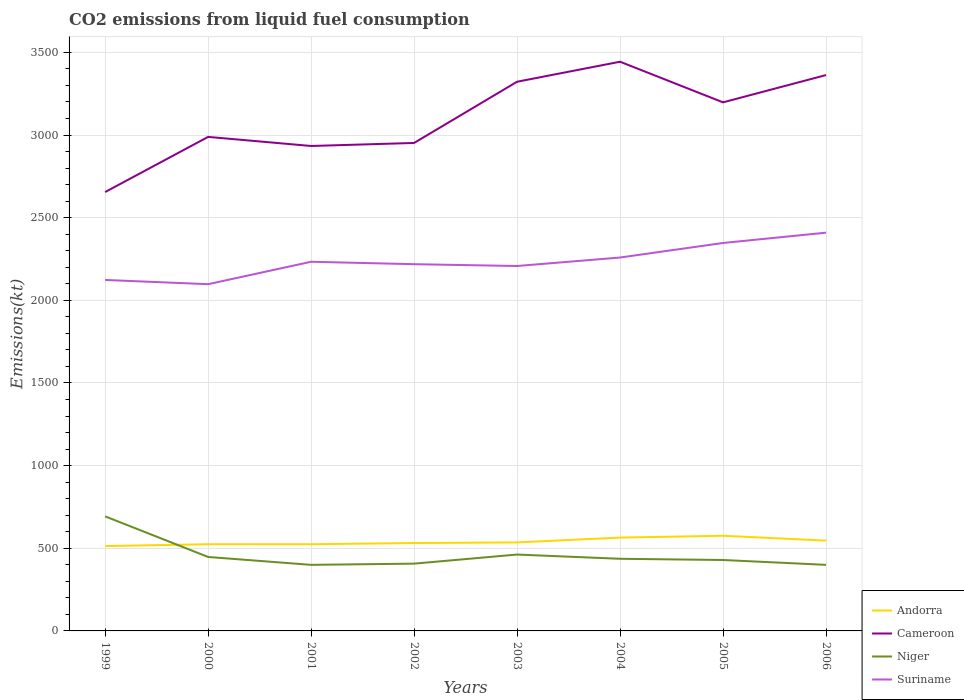How many different coloured lines are there?
Ensure brevity in your answer.  4. Is the number of lines equal to the number of legend labels?
Your answer should be very brief. Yes. Across all years, what is the maximum amount of CO2 emitted in Andorra?
Provide a short and direct response. 513.38. In which year was the amount of CO2 emitted in Niger maximum?
Your answer should be very brief. 2001. What is the total amount of CO2 emitted in Andorra in the graph?
Your answer should be compact. -62.34. What is the difference between the highest and the second highest amount of CO2 emitted in Cameroon?
Give a very brief answer. 788.41. What is the difference between the highest and the lowest amount of CO2 emitted in Andorra?
Your answer should be compact. 3. Is the amount of CO2 emitted in Niger strictly greater than the amount of CO2 emitted in Suriname over the years?
Your answer should be compact. Yes. How many years are there in the graph?
Provide a succinct answer. 8. What is the difference between two consecutive major ticks on the Y-axis?
Offer a very short reply. 500. Are the values on the major ticks of Y-axis written in scientific E-notation?
Your response must be concise. No. Does the graph contain grids?
Your response must be concise. Yes. How many legend labels are there?
Your answer should be very brief. 4. What is the title of the graph?
Keep it short and to the point. CO2 emissions from liquid fuel consumption. Does "Morocco" appear as one of the legend labels in the graph?
Keep it short and to the point. No. What is the label or title of the Y-axis?
Your answer should be compact. Emissions(kt). What is the Emissions(kt) in Andorra in 1999?
Make the answer very short. 513.38. What is the Emissions(kt) in Cameroon in 1999?
Your response must be concise. 2654.91. What is the Emissions(kt) of Niger in 1999?
Offer a very short reply. 693.06. What is the Emissions(kt) of Suriname in 1999?
Make the answer very short. 2123.19. What is the Emissions(kt) of Andorra in 2000?
Provide a short and direct response. 524.38. What is the Emissions(kt) in Cameroon in 2000?
Your answer should be very brief. 2988.61. What is the Emissions(kt) of Niger in 2000?
Provide a succinct answer. 447.37. What is the Emissions(kt) in Suriname in 2000?
Your answer should be very brief. 2097.52. What is the Emissions(kt) of Andorra in 2001?
Your answer should be very brief. 524.38. What is the Emissions(kt) of Cameroon in 2001?
Offer a very short reply. 2933.6. What is the Emissions(kt) of Niger in 2001?
Ensure brevity in your answer.  399.7. What is the Emissions(kt) in Suriname in 2001?
Your response must be concise. 2233.2. What is the Emissions(kt) in Andorra in 2002?
Your response must be concise. 531.72. What is the Emissions(kt) in Cameroon in 2002?
Give a very brief answer. 2951.93. What is the Emissions(kt) of Niger in 2002?
Your answer should be compact. 407.04. What is the Emissions(kt) in Suriname in 2002?
Your answer should be compact. 2218.53. What is the Emissions(kt) in Andorra in 2003?
Your answer should be compact. 535.38. What is the Emissions(kt) of Cameroon in 2003?
Give a very brief answer. 3322.3. What is the Emissions(kt) in Niger in 2003?
Your answer should be compact. 462.04. What is the Emissions(kt) in Suriname in 2003?
Make the answer very short. 2207.53. What is the Emissions(kt) of Andorra in 2004?
Ensure brevity in your answer.  564.72. What is the Emissions(kt) of Cameroon in 2004?
Ensure brevity in your answer.  3443.31. What is the Emissions(kt) of Niger in 2004?
Your answer should be very brief. 436.37. What is the Emissions(kt) in Suriname in 2004?
Your response must be concise. 2258.87. What is the Emissions(kt) of Andorra in 2005?
Provide a succinct answer. 575.72. What is the Emissions(kt) in Cameroon in 2005?
Provide a short and direct response. 3197.62. What is the Emissions(kt) of Niger in 2005?
Provide a short and direct response. 429.04. What is the Emissions(kt) in Suriname in 2005?
Provide a succinct answer. 2346.88. What is the Emissions(kt) of Andorra in 2006?
Offer a very short reply. 546.38. What is the Emissions(kt) in Cameroon in 2006?
Your answer should be very brief. 3362.64. What is the Emissions(kt) in Niger in 2006?
Keep it short and to the point. 399.7. What is the Emissions(kt) of Suriname in 2006?
Your answer should be very brief. 2409.22. Across all years, what is the maximum Emissions(kt) of Andorra?
Make the answer very short. 575.72. Across all years, what is the maximum Emissions(kt) in Cameroon?
Make the answer very short. 3443.31. Across all years, what is the maximum Emissions(kt) of Niger?
Make the answer very short. 693.06. Across all years, what is the maximum Emissions(kt) in Suriname?
Offer a terse response. 2409.22. Across all years, what is the minimum Emissions(kt) of Andorra?
Give a very brief answer. 513.38. Across all years, what is the minimum Emissions(kt) of Cameroon?
Ensure brevity in your answer.  2654.91. Across all years, what is the minimum Emissions(kt) of Niger?
Your response must be concise. 399.7. Across all years, what is the minimum Emissions(kt) in Suriname?
Provide a succinct answer. 2097.52. What is the total Emissions(kt) in Andorra in the graph?
Make the answer very short. 4316.06. What is the total Emissions(kt) in Cameroon in the graph?
Provide a succinct answer. 2.49e+04. What is the total Emissions(kt) in Niger in the graph?
Ensure brevity in your answer.  3674.33. What is the total Emissions(kt) in Suriname in the graph?
Keep it short and to the point. 1.79e+04. What is the difference between the Emissions(kt) in Andorra in 1999 and that in 2000?
Keep it short and to the point. -11. What is the difference between the Emissions(kt) in Cameroon in 1999 and that in 2000?
Offer a terse response. -333.7. What is the difference between the Emissions(kt) of Niger in 1999 and that in 2000?
Your answer should be compact. 245.69. What is the difference between the Emissions(kt) in Suriname in 1999 and that in 2000?
Provide a short and direct response. 25.67. What is the difference between the Emissions(kt) of Andorra in 1999 and that in 2001?
Your answer should be compact. -11. What is the difference between the Emissions(kt) in Cameroon in 1999 and that in 2001?
Make the answer very short. -278.69. What is the difference between the Emissions(kt) in Niger in 1999 and that in 2001?
Your answer should be compact. 293.36. What is the difference between the Emissions(kt) of Suriname in 1999 and that in 2001?
Offer a very short reply. -110.01. What is the difference between the Emissions(kt) of Andorra in 1999 and that in 2002?
Offer a terse response. -18.34. What is the difference between the Emissions(kt) of Cameroon in 1999 and that in 2002?
Provide a succinct answer. -297.03. What is the difference between the Emissions(kt) of Niger in 1999 and that in 2002?
Your answer should be very brief. 286.03. What is the difference between the Emissions(kt) of Suriname in 1999 and that in 2002?
Ensure brevity in your answer.  -95.34. What is the difference between the Emissions(kt) of Andorra in 1999 and that in 2003?
Give a very brief answer. -22. What is the difference between the Emissions(kt) in Cameroon in 1999 and that in 2003?
Provide a succinct answer. -667.39. What is the difference between the Emissions(kt) in Niger in 1999 and that in 2003?
Keep it short and to the point. 231.02. What is the difference between the Emissions(kt) of Suriname in 1999 and that in 2003?
Keep it short and to the point. -84.34. What is the difference between the Emissions(kt) of Andorra in 1999 and that in 2004?
Offer a terse response. -51.34. What is the difference between the Emissions(kt) of Cameroon in 1999 and that in 2004?
Offer a very short reply. -788.4. What is the difference between the Emissions(kt) of Niger in 1999 and that in 2004?
Offer a terse response. 256.69. What is the difference between the Emissions(kt) in Suriname in 1999 and that in 2004?
Make the answer very short. -135.68. What is the difference between the Emissions(kt) of Andorra in 1999 and that in 2005?
Provide a succinct answer. -62.34. What is the difference between the Emissions(kt) of Cameroon in 1999 and that in 2005?
Your answer should be very brief. -542.72. What is the difference between the Emissions(kt) of Niger in 1999 and that in 2005?
Provide a succinct answer. 264.02. What is the difference between the Emissions(kt) of Suriname in 1999 and that in 2005?
Ensure brevity in your answer.  -223.69. What is the difference between the Emissions(kt) in Andorra in 1999 and that in 2006?
Your answer should be very brief. -33. What is the difference between the Emissions(kt) in Cameroon in 1999 and that in 2006?
Ensure brevity in your answer.  -707.73. What is the difference between the Emissions(kt) in Niger in 1999 and that in 2006?
Provide a short and direct response. 293.36. What is the difference between the Emissions(kt) in Suriname in 1999 and that in 2006?
Offer a very short reply. -286.03. What is the difference between the Emissions(kt) of Cameroon in 2000 and that in 2001?
Keep it short and to the point. 55.01. What is the difference between the Emissions(kt) of Niger in 2000 and that in 2001?
Your response must be concise. 47.67. What is the difference between the Emissions(kt) of Suriname in 2000 and that in 2001?
Your answer should be compact. -135.68. What is the difference between the Emissions(kt) of Andorra in 2000 and that in 2002?
Offer a terse response. -7.33. What is the difference between the Emissions(kt) in Cameroon in 2000 and that in 2002?
Provide a succinct answer. 36.67. What is the difference between the Emissions(kt) of Niger in 2000 and that in 2002?
Offer a very short reply. 40.34. What is the difference between the Emissions(kt) in Suriname in 2000 and that in 2002?
Ensure brevity in your answer.  -121.01. What is the difference between the Emissions(kt) in Andorra in 2000 and that in 2003?
Offer a terse response. -11. What is the difference between the Emissions(kt) in Cameroon in 2000 and that in 2003?
Your response must be concise. -333.7. What is the difference between the Emissions(kt) in Niger in 2000 and that in 2003?
Offer a very short reply. -14.67. What is the difference between the Emissions(kt) of Suriname in 2000 and that in 2003?
Your answer should be very brief. -110.01. What is the difference between the Emissions(kt) of Andorra in 2000 and that in 2004?
Provide a succinct answer. -40.34. What is the difference between the Emissions(kt) of Cameroon in 2000 and that in 2004?
Provide a short and direct response. -454.71. What is the difference between the Emissions(kt) of Niger in 2000 and that in 2004?
Give a very brief answer. 11. What is the difference between the Emissions(kt) in Suriname in 2000 and that in 2004?
Keep it short and to the point. -161.35. What is the difference between the Emissions(kt) of Andorra in 2000 and that in 2005?
Make the answer very short. -51.34. What is the difference between the Emissions(kt) of Cameroon in 2000 and that in 2005?
Make the answer very short. -209.02. What is the difference between the Emissions(kt) in Niger in 2000 and that in 2005?
Provide a succinct answer. 18.34. What is the difference between the Emissions(kt) of Suriname in 2000 and that in 2005?
Ensure brevity in your answer.  -249.36. What is the difference between the Emissions(kt) in Andorra in 2000 and that in 2006?
Offer a very short reply. -22. What is the difference between the Emissions(kt) of Cameroon in 2000 and that in 2006?
Make the answer very short. -374.03. What is the difference between the Emissions(kt) in Niger in 2000 and that in 2006?
Keep it short and to the point. 47.67. What is the difference between the Emissions(kt) of Suriname in 2000 and that in 2006?
Make the answer very short. -311.69. What is the difference between the Emissions(kt) of Andorra in 2001 and that in 2002?
Offer a very short reply. -7.33. What is the difference between the Emissions(kt) in Cameroon in 2001 and that in 2002?
Provide a short and direct response. -18.34. What is the difference between the Emissions(kt) of Niger in 2001 and that in 2002?
Keep it short and to the point. -7.33. What is the difference between the Emissions(kt) of Suriname in 2001 and that in 2002?
Offer a very short reply. 14.67. What is the difference between the Emissions(kt) of Andorra in 2001 and that in 2003?
Give a very brief answer. -11. What is the difference between the Emissions(kt) of Cameroon in 2001 and that in 2003?
Make the answer very short. -388.7. What is the difference between the Emissions(kt) in Niger in 2001 and that in 2003?
Provide a succinct answer. -62.34. What is the difference between the Emissions(kt) in Suriname in 2001 and that in 2003?
Give a very brief answer. 25.67. What is the difference between the Emissions(kt) of Andorra in 2001 and that in 2004?
Keep it short and to the point. -40.34. What is the difference between the Emissions(kt) in Cameroon in 2001 and that in 2004?
Offer a very short reply. -509.71. What is the difference between the Emissions(kt) of Niger in 2001 and that in 2004?
Provide a succinct answer. -36.67. What is the difference between the Emissions(kt) of Suriname in 2001 and that in 2004?
Your answer should be very brief. -25.67. What is the difference between the Emissions(kt) of Andorra in 2001 and that in 2005?
Provide a short and direct response. -51.34. What is the difference between the Emissions(kt) in Cameroon in 2001 and that in 2005?
Keep it short and to the point. -264.02. What is the difference between the Emissions(kt) in Niger in 2001 and that in 2005?
Provide a succinct answer. -29.34. What is the difference between the Emissions(kt) in Suriname in 2001 and that in 2005?
Keep it short and to the point. -113.68. What is the difference between the Emissions(kt) in Andorra in 2001 and that in 2006?
Provide a short and direct response. -22. What is the difference between the Emissions(kt) of Cameroon in 2001 and that in 2006?
Your response must be concise. -429.04. What is the difference between the Emissions(kt) in Niger in 2001 and that in 2006?
Your response must be concise. 0. What is the difference between the Emissions(kt) of Suriname in 2001 and that in 2006?
Keep it short and to the point. -176.02. What is the difference between the Emissions(kt) of Andorra in 2002 and that in 2003?
Your answer should be very brief. -3.67. What is the difference between the Emissions(kt) of Cameroon in 2002 and that in 2003?
Offer a terse response. -370.37. What is the difference between the Emissions(kt) of Niger in 2002 and that in 2003?
Give a very brief answer. -55.01. What is the difference between the Emissions(kt) in Suriname in 2002 and that in 2003?
Ensure brevity in your answer.  11. What is the difference between the Emissions(kt) of Andorra in 2002 and that in 2004?
Give a very brief answer. -33. What is the difference between the Emissions(kt) in Cameroon in 2002 and that in 2004?
Ensure brevity in your answer.  -491.38. What is the difference between the Emissions(kt) of Niger in 2002 and that in 2004?
Provide a succinct answer. -29.34. What is the difference between the Emissions(kt) in Suriname in 2002 and that in 2004?
Provide a short and direct response. -40.34. What is the difference between the Emissions(kt) of Andorra in 2002 and that in 2005?
Your answer should be compact. -44. What is the difference between the Emissions(kt) in Cameroon in 2002 and that in 2005?
Offer a terse response. -245.69. What is the difference between the Emissions(kt) of Niger in 2002 and that in 2005?
Ensure brevity in your answer.  -22. What is the difference between the Emissions(kt) of Suriname in 2002 and that in 2005?
Provide a short and direct response. -128.34. What is the difference between the Emissions(kt) in Andorra in 2002 and that in 2006?
Make the answer very short. -14.67. What is the difference between the Emissions(kt) of Cameroon in 2002 and that in 2006?
Offer a terse response. -410.7. What is the difference between the Emissions(kt) of Niger in 2002 and that in 2006?
Your answer should be compact. 7.33. What is the difference between the Emissions(kt) in Suriname in 2002 and that in 2006?
Make the answer very short. -190.68. What is the difference between the Emissions(kt) in Andorra in 2003 and that in 2004?
Offer a very short reply. -29.34. What is the difference between the Emissions(kt) of Cameroon in 2003 and that in 2004?
Your answer should be compact. -121.01. What is the difference between the Emissions(kt) in Niger in 2003 and that in 2004?
Your answer should be compact. 25.67. What is the difference between the Emissions(kt) in Suriname in 2003 and that in 2004?
Make the answer very short. -51.34. What is the difference between the Emissions(kt) of Andorra in 2003 and that in 2005?
Provide a succinct answer. -40.34. What is the difference between the Emissions(kt) of Cameroon in 2003 and that in 2005?
Give a very brief answer. 124.68. What is the difference between the Emissions(kt) in Niger in 2003 and that in 2005?
Your answer should be very brief. 33. What is the difference between the Emissions(kt) of Suriname in 2003 and that in 2005?
Keep it short and to the point. -139.35. What is the difference between the Emissions(kt) of Andorra in 2003 and that in 2006?
Give a very brief answer. -11. What is the difference between the Emissions(kt) in Cameroon in 2003 and that in 2006?
Offer a terse response. -40.34. What is the difference between the Emissions(kt) in Niger in 2003 and that in 2006?
Give a very brief answer. 62.34. What is the difference between the Emissions(kt) in Suriname in 2003 and that in 2006?
Provide a short and direct response. -201.69. What is the difference between the Emissions(kt) in Andorra in 2004 and that in 2005?
Make the answer very short. -11. What is the difference between the Emissions(kt) of Cameroon in 2004 and that in 2005?
Your answer should be very brief. 245.69. What is the difference between the Emissions(kt) of Niger in 2004 and that in 2005?
Your answer should be compact. 7.33. What is the difference between the Emissions(kt) in Suriname in 2004 and that in 2005?
Keep it short and to the point. -88.01. What is the difference between the Emissions(kt) of Andorra in 2004 and that in 2006?
Your response must be concise. 18.34. What is the difference between the Emissions(kt) in Cameroon in 2004 and that in 2006?
Your answer should be very brief. 80.67. What is the difference between the Emissions(kt) in Niger in 2004 and that in 2006?
Your answer should be compact. 36.67. What is the difference between the Emissions(kt) in Suriname in 2004 and that in 2006?
Provide a short and direct response. -150.35. What is the difference between the Emissions(kt) of Andorra in 2005 and that in 2006?
Ensure brevity in your answer.  29.34. What is the difference between the Emissions(kt) in Cameroon in 2005 and that in 2006?
Give a very brief answer. -165.01. What is the difference between the Emissions(kt) of Niger in 2005 and that in 2006?
Ensure brevity in your answer.  29.34. What is the difference between the Emissions(kt) in Suriname in 2005 and that in 2006?
Give a very brief answer. -62.34. What is the difference between the Emissions(kt) in Andorra in 1999 and the Emissions(kt) in Cameroon in 2000?
Provide a succinct answer. -2475.22. What is the difference between the Emissions(kt) of Andorra in 1999 and the Emissions(kt) of Niger in 2000?
Ensure brevity in your answer.  66.01. What is the difference between the Emissions(kt) of Andorra in 1999 and the Emissions(kt) of Suriname in 2000?
Make the answer very short. -1584.14. What is the difference between the Emissions(kt) in Cameroon in 1999 and the Emissions(kt) in Niger in 2000?
Offer a very short reply. 2207.53. What is the difference between the Emissions(kt) of Cameroon in 1999 and the Emissions(kt) of Suriname in 2000?
Your answer should be very brief. 557.38. What is the difference between the Emissions(kt) of Niger in 1999 and the Emissions(kt) of Suriname in 2000?
Provide a succinct answer. -1404.46. What is the difference between the Emissions(kt) in Andorra in 1999 and the Emissions(kt) in Cameroon in 2001?
Ensure brevity in your answer.  -2420.22. What is the difference between the Emissions(kt) in Andorra in 1999 and the Emissions(kt) in Niger in 2001?
Your answer should be compact. 113.68. What is the difference between the Emissions(kt) in Andorra in 1999 and the Emissions(kt) in Suriname in 2001?
Offer a terse response. -1719.82. What is the difference between the Emissions(kt) in Cameroon in 1999 and the Emissions(kt) in Niger in 2001?
Your answer should be very brief. 2255.2. What is the difference between the Emissions(kt) in Cameroon in 1999 and the Emissions(kt) in Suriname in 2001?
Provide a succinct answer. 421.7. What is the difference between the Emissions(kt) of Niger in 1999 and the Emissions(kt) of Suriname in 2001?
Provide a short and direct response. -1540.14. What is the difference between the Emissions(kt) in Andorra in 1999 and the Emissions(kt) in Cameroon in 2002?
Your answer should be compact. -2438.55. What is the difference between the Emissions(kt) in Andorra in 1999 and the Emissions(kt) in Niger in 2002?
Give a very brief answer. 106.34. What is the difference between the Emissions(kt) in Andorra in 1999 and the Emissions(kt) in Suriname in 2002?
Offer a very short reply. -1705.15. What is the difference between the Emissions(kt) of Cameroon in 1999 and the Emissions(kt) of Niger in 2002?
Give a very brief answer. 2247.87. What is the difference between the Emissions(kt) in Cameroon in 1999 and the Emissions(kt) in Suriname in 2002?
Offer a very short reply. 436.37. What is the difference between the Emissions(kt) of Niger in 1999 and the Emissions(kt) of Suriname in 2002?
Give a very brief answer. -1525.47. What is the difference between the Emissions(kt) in Andorra in 1999 and the Emissions(kt) in Cameroon in 2003?
Your response must be concise. -2808.92. What is the difference between the Emissions(kt) in Andorra in 1999 and the Emissions(kt) in Niger in 2003?
Your answer should be compact. 51.34. What is the difference between the Emissions(kt) of Andorra in 1999 and the Emissions(kt) of Suriname in 2003?
Keep it short and to the point. -1694.15. What is the difference between the Emissions(kt) in Cameroon in 1999 and the Emissions(kt) in Niger in 2003?
Make the answer very short. 2192.87. What is the difference between the Emissions(kt) in Cameroon in 1999 and the Emissions(kt) in Suriname in 2003?
Provide a succinct answer. 447.37. What is the difference between the Emissions(kt) in Niger in 1999 and the Emissions(kt) in Suriname in 2003?
Provide a short and direct response. -1514.47. What is the difference between the Emissions(kt) in Andorra in 1999 and the Emissions(kt) in Cameroon in 2004?
Provide a short and direct response. -2929.93. What is the difference between the Emissions(kt) of Andorra in 1999 and the Emissions(kt) of Niger in 2004?
Your answer should be very brief. 77.01. What is the difference between the Emissions(kt) in Andorra in 1999 and the Emissions(kt) in Suriname in 2004?
Provide a succinct answer. -1745.49. What is the difference between the Emissions(kt) in Cameroon in 1999 and the Emissions(kt) in Niger in 2004?
Ensure brevity in your answer.  2218.53. What is the difference between the Emissions(kt) of Cameroon in 1999 and the Emissions(kt) of Suriname in 2004?
Provide a succinct answer. 396.04. What is the difference between the Emissions(kt) of Niger in 1999 and the Emissions(kt) of Suriname in 2004?
Provide a succinct answer. -1565.81. What is the difference between the Emissions(kt) of Andorra in 1999 and the Emissions(kt) of Cameroon in 2005?
Ensure brevity in your answer.  -2684.24. What is the difference between the Emissions(kt) in Andorra in 1999 and the Emissions(kt) in Niger in 2005?
Ensure brevity in your answer.  84.34. What is the difference between the Emissions(kt) of Andorra in 1999 and the Emissions(kt) of Suriname in 2005?
Your answer should be very brief. -1833.5. What is the difference between the Emissions(kt) in Cameroon in 1999 and the Emissions(kt) in Niger in 2005?
Make the answer very short. 2225.87. What is the difference between the Emissions(kt) of Cameroon in 1999 and the Emissions(kt) of Suriname in 2005?
Provide a short and direct response. 308.03. What is the difference between the Emissions(kt) in Niger in 1999 and the Emissions(kt) in Suriname in 2005?
Offer a very short reply. -1653.82. What is the difference between the Emissions(kt) of Andorra in 1999 and the Emissions(kt) of Cameroon in 2006?
Your response must be concise. -2849.26. What is the difference between the Emissions(kt) in Andorra in 1999 and the Emissions(kt) in Niger in 2006?
Make the answer very short. 113.68. What is the difference between the Emissions(kt) of Andorra in 1999 and the Emissions(kt) of Suriname in 2006?
Give a very brief answer. -1895.84. What is the difference between the Emissions(kt) of Cameroon in 1999 and the Emissions(kt) of Niger in 2006?
Your answer should be compact. 2255.2. What is the difference between the Emissions(kt) of Cameroon in 1999 and the Emissions(kt) of Suriname in 2006?
Offer a very short reply. 245.69. What is the difference between the Emissions(kt) in Niger in 1999 and the Emissions(kt) in Suriname in 2006?
Ensure brevity in your answer.  -1716.16. What is the difference between the Emissions(kt) of Andorra in 2000 and the Emissions(kt) of Cameroon in 2001?
Provide a short and direct response. -2409.22. What is the difference between the Emissions(kt) of Andorra in 2000 and the Emissions(kt) of Niger in 2001?
Your response must be concise. 124.68. What is the difference between the Emissions(kt) in Andorra in 2000 and the Emissions(kt) in Suriname in 2001?
Offer a terse response. -1708.82. What is the difference between the Emissions(kt) of Cameroon in 2000 and the Emissions(kt) of Niger in 2001?
Offer a very short reply. 2588.9. What is the difference between the Emissions(kt) of Cameroon in 2000 and the Emissions(kt) of Suriname in 2001?
Your answer should be compact. 755.4. What is the difference between the Emissions(kt) of Niger in 2000 and the Emissions(kt) of Suriname in 2001?
Offer a terse response. -1785.83. What is the difference between the Emissions(kt) in Andorra in 2000 and the Emissions(kt) in Cameroon in 2002?
Your answer should be very brief. -2427.55. What is the difference between the Emissions(kt) of Andorra in 2000 and the Emissions(kt) of Niger in 2002?
Your answer should be very brief. 117.34. What is the difference between the Emissions(kt) of Andorra in 2000 and the Emissions(kt) of Suriname in 2002?
Provide a short and direct response. -1694.15. What is the difference between the Emissions(kt) in Cameroon in 2000 and the Emissions(kt) in Niger in 2002?
Your answer should be compact. 2581.57. What is the difference between the Emissions(kt) in Cameroon in 2000 and the Emissions(kt) in Suriname in 2002?
Ensure brevity in your answer.  770.07. What is the difference between the Emissions(kt) of Niger in 2000 and the Emissions(kt) of Suriname in 2002?
Offer a very short reply. -1771.16. What is the difference between the Emissions(kt) in Andorra in 2000 and the Emissions(kt) in Cameroon in 2003?
Provide a succinct answer. -2797.92. What is the difference between the Emissions(kt) in Andorra in 2000 and the Emissions(kt) in Niger in 2003?
Keep it short and to the point. 62.34. What is the difference between the Emissions(kt) of Andorra in 2000 and the Emissions(kt) of Suriname in 2003?
Provide a succinct answer. -1683.15. What is the difference between the Emissions(kt) in Cameroon in 2000 and the Emissions(kt) in Niger in 2003?
Give a very brief answer. 2526.56. What is the difference between the Emissions(kt) in Cameroon in 2000 and the Emissions(kt) in Suriname in 2003?
Your answer should be compact. 781.07. What is the difference between the Emissions(kt) of Niger in 2000 and the Emissions(kt) of Suriname in 2003?
Offer a very short reply. -1760.16. What is the difference between the Emissions(kt) of Andorra in 2000 and the Emissions(kt) of Cameroon in 2004?
Ensure brevity in your answer.  -2918.93. What is the difference between the Emissions(kt) of Andorra in 2000 and the Emissions(kt) of Niger in 2004?
Keep it short and to the point. 88.01. What is the difference between the Emissions(kt) of Andorra in 2000 and the Emissions(kt) of Suriname in 2004?
Provide a short and direct response. -1734.49. What is the difference between the Emissions(kt) of Cameroon in 2000 and the Emissions(kt) of Niger in 2004?
Your response must be concise. 2552.23. What is the difference between the Emissions(kt) of Cameroon in 2000 and the Emissions(kt) of Suriname in 2004?
Your answer should be very brief. 729.73. What is the difference between the Emissions(kt) in Niger in 2000 and the Emissions(kt) in Suriname in 2004?
Give a very brief answer. -1811.5. What is the difference between the Emissions(kt) of Andorra in 2000 and the Emissions(kt) of Cameroon in 2005?
Ensure brevity in your answer.  -2673.24. What is the difference between the Emissions(kt) in Andorra in 2000 and the Emissions(kt) in Niger in 2005?
Provide a short and direct response. 95.34. What is the difference between the Emissions(kt) of Andorra in 2000 and the Emissions(kt) of Suriname in 2005?
Offer a terse response. -1822.5. What is the difference between the Emissions(kt) in Cameroon in 2000 and the Emissions(kt) in Niger in 2005?
Your answer should be very brief. 2559.57. What is the difference between the Emissions(kt) in Cameroon in 2000 and the Emissions(kt) in Suriname in 2005?
Offer a very short reply. 641.73. What is the difference between the Emissions(kt) of Niger in 2000 and the Emissions(kt) of Suriname in 2005?
Provide a succinct answer. -1899.51. What is the difference between the Emissions(kt) of Andorra in 2000 and the Emissions(kt) of Cameroon in 2006?
Keep it short and to the point. -2838.26. What is the difference between the Emissions(kt) in Andorra in 2000 and the Emissions(kt) in Niger in 2006?
Offer a terse response. 124.68. What is the difference between the Emissions(kt) in Andorra in 2000 and the Emissions(kt) in Suriname in 2006?
Make the answer very short. -1884.84. What is the difference between the Emissions(kt) of Cameroon in 2000 and the Emissions(kt) of Niger in 2006?
Your answer should be very brief. 2588.9. What is the difference between the Emissions(kt) of Cameroon in 2000 and the Emissions(kt) of Suriname in 2006?
Offer a very short reply. 579.39. What is the difference between the Emissions(kt) of Niger in 2000 and the Emissions(kt) of Suriname in 2006?
Provide a short and direct response. -1961.85. What is the difference between the Emissions(kt) of Andorra in 2001 and the Emissions(kt) of Cameroon in 2002?
Your answer should be compact. -2427.55. What is the difference between the Emissions(kt) of Andorra in 2001 and the Emissions(kt) of Niger in 2002?
Provide a succinct answer. 117.34. What is the difference between the Emissions(kt) of Andorra in 2001 and the Emissions(kt) of Suriname in 2002?
Provide a short and direct response. -1694.15. What is the difference between the Emissions(kt) in Cameroon in 2001 and the Emissions(kt) in Niger in 2002?
Your response must be concise. 2526.56. What is the difference between the Emissions(kt) in Cameroon in 2001 and the Emissions(kt) in Suriname in 2002?
Provide a succinct answer. 715.07. What is the difference between the Emissions(kt) of Niger in 2001 and the Emissions(kt) of Suriname in 2002?
Provide a short and direct response. -1818.83. What is the difference between the Emissions(kt) in Andorra in 2001 and the Emissions(kt) in Cameroon in 2003?
Your response must be concise. -2797.92. What is the difference between the Emissions(kt) in Andorra in 2001 and the Emissions(kt) in Niger in 2003?
Your answer should be compact. 62.34. What is the difference between the Emissions(kt) in Andorra in 2001 and the Emissions(kt) in Suriname in 2003?
Your answer should be very brief. -1683.15. What is the difference between the Emissions(kt) in Cameroon in 2001 and the Emissions(kt) in Niger in 2003?
Give a very brief answer. 2471.56. What is the difference between the Emissions(kt) in Cameroon in 2001 and the Emissions(kt) in Suriname in 2003?
Offer a terse response. 726.07. What is the difference between the Emissions(kt) in Niger in 2001 and the Emissions(kt) in Suriname in 2003?
Make the answer very short. -1807.83. What is the difference between the Emissions(kt) in Andorra in 2001 and the Emissions(kt) in Cameroon in 2004?
Make the answer very short. -2918.93. What is the difference between the Emissions(kt) in Andorra in 2001 and the Emissions(kt) in Niger in 2004?
Offer a very short reply. 88.01. What is the difference between the Emissions(kt) in Andorra in 2001 and the Emissions(kt) in Suriname in 2004?
Your answer should be very brief. -1734.49. What is the difference between the Emissions(kt) in Cameroon in 2001 and the Emissions(kt) in Niger in 2004?
Ensure brevity in your answer.  2497.23. What is the difference between the Emissions(kt) in Cameroon in 2001 and the Emissions(kt) in Suriname in 2004?
Keep it short and to the point. 674.73. What is the difference between the Emissions(kt) of Niger in 2001 and the Emissions(kt) of Suriname in 2004?
Your answer should be very brief. -1859.17. What is the difference between the Emissions(kt) of Andorra in 2001 and the Emissions(kt) of Cameroon in 2005?
Your answer should be very brief. -2673.24. What is the difference between the Emissions(kt) of Andorra in 2001 and the Emissions(kt) of Niger in 2005?
Your answer should be very brief. 95.34. What is the difference between the Emissions(kt) in Andorra in 2001 and the Emissions(kt) in Suriname in 2005?
Ensure brevity in your answer.  -1822.5. What is the difference between the Emissions(kt) in Cameroon in 2001 and the Emissions(kt) in Niger in 2005?
Your answer should be very brief. 2504.56. What is the difference between the Emissions(kt) of Cameroon in 2001 and the Emissions(kt) of Suriname in 2005?
Your answer should be very brief. 586.72. What is the difference between the Emissions(kt) in Niger in 2001 and the Emissions(kt) in Suriname in 2005?
Offer a very short reply. -1947.18. What is the difference between the Emissions(kt) in Andorra in 2001 and the Emissions(kt) in Cameroon in 2006?
Ensure brevity in your answer.  -2838.26. What is the difference between the Emissions(kt) in Andorra in 2001 and the Emissions(kt) in Niger in 2006?
Give a very brief answer. 124.68. What is the difference between the Emissions(kt) in Andorra in 2001 and the Emissions(kt) in Suriname in 2006?
Your response must be concise. -1884.84. What is the difference between the Emissions(kt) in Cameroon in 2001 and the Emissions(kt) in Niger in 2006?
Keep it short and to the point. 2533.9. What is the difference between the Emissions(kt) in Cameroon in 2001 and the Emissions(kt) in Suriname in 2006?
Your answer should be compact. 524.38. What is the difference between the Emissions(kt) in Niger in 2001 and the Emissions(kt) in Suriname in 2006?
Give a very brief answer. -2009.52. What is the difference between the Emissions(kt) in Andorra in 2002 and the Emissions(kt) in Cameroon in 2003?
Ensure brevity in your answer.  -2790.59. What is the difference between the Emissions(kt) of Andorra in 2002 and the Emissions(kt) of Niger in 2003?
Provide a succinct answer. 69.67. What is the difference between the Emissions(kt) of Andorra in 2002 and the Emissions(kt) of Suriname in 2003?
Offer a very short reply. -1675.82. What is the difference between the Emissions(kt) in Cameroon in 2002 and the Emissions(kt) in Niger in 2003?
Give a very brief answer. 2489.89. What is the difference between the Emissions(kt) in Cameroon in 2002 and the Emissions(kt) in Suriname in 2003?
Ensure brevity in your answer.  744.4. What is the difference between the Emissions(kt) in Niger in 2002 and the Emissions(kt) in Suriname in 2003?
Offer a terse response. -1800.5. What is the difference between the Emissions(kt) in Andorra in 2002 and the Emissions(kt) in Cameroon in 2004?
Offer a very short reply. -2911.6. What is the difference between the Emissions(kt) of Andorra in 2002 and the Emissions(kt) of Niger in 2004?
Your answer should be compact. 95.34. What is the difference between the Emissions(kt) in Andorra in 2002 and the Emissions(kt) in Suriname in 2004?
Provide a short and direct response. -1727.16. What is the difference between the Emissions(kt) in Cameroon in 2002 and the Emissions(kt) in Niger in 2004?
Your response must be concise. 2515.56. What is the difference between the Emissions(kt) of Cameroon in 2002 and the Emissions(kt) of Suriname in 2004?
Make the answer very short. 693.06. What is the difference between the Emissions(kt) of Niger in 2002 and the Emissions(kt) of Suriname in 2004?
Provide a succinct answer. -1851.84. What is the difference between the Emissions(kt) of Andorra in 2002 and the Emissions(kt) of Cameroon in 2005?
Provide a short and direct response. -2665.91. What is the difference between the Emissions(kt) of Andorra in 2002 and the Emissions(kt) of Niger in 2005?
Keep it short and to the point. 102.68. What is the difference between the Emissions(kt) in Andorra in 2002 and the Emissions(kt) in Suriname in 2005?
Your answer should be very brief. -1815.16. What is the difference between the Emissions(kt) of Cameroon in 2002 and the Emissions(kt) of Niger in 2005?
Keep it short and to the point. 2522.9. What is the difference between the Emissions(kt) of Cameroon in 2002 and the Emissions(kt) of Suriname in 2005?
Give a very brief answer. 605.05. What is the difference between the Emissions(kt) of Niger in 2002 and the Emissions(kt) of Suriname in 2005?
Your answer should be very brief. -1939.84. What is the difference between the Emissions(kt) in Andorra in 2002 and the Emissions(kt) in Cameroon in 2006?
Provide a succinct answer. -2830.92. What is the difference between the Emissions(kt) in Andorra in 2002 and the Emissions(kt) in Niger in 2006?
Offer a very short reply. 132.01. What is the difference between the Emissions(kt) of Andorra in 2002 and the Emissions(kt) of Suriname in 2006?
Your answer should be very brief. -1877.5. What is the difference between the Emissions(kt) in Cameroon in 2002 and the Emissions(kt) in Niger in 2006?
Ensure brevity in your answer.  2552.23. What is the difference between the Emissions(kt) of Cameroon in 2002 and the Emissions(kt) of Suriname in 2006?
Provide a succinct answer. 542.72. What is the difference between the Emissions(kt) of Niger in 2002 and the Emissions(kt) of Suriname in 2006?
Keep it short and to the point. -2002.18. What is the difference between the Emissions(kt) of Andorra in 2003 and the Emissions(kt) of Cameroon in 2004?
Keep it short and to the point. -2907.93. What is the difference between the Emissions(kt) in Andorra in 2003 and the Emissions(kt) in Niger in 2004?
Your answer should be compact. 99.01. What is the difference between the Emissions(kt) of Andorra in 2003 and the Emissions(kt) of Suriname in 2004?
Provide a succinct answer. -1723.49. What is the difference between the Emissions(kt) of Cameroon in 2003 and the Emissions(kt) of Niger in 2004?
Provide a succinct answer. 2885.93. What is the difference between the Emissions(kt) in Cameroon in 2003 and the Emissions(kt) in Suriname in 2004?
Offer a very short reply. 1063.43. What is the difference between the Emissions(kt) in Niger in 2003 and the Emissions(kt) in Suriname in 2004?
Provide a short and direct response. -1796.83. What is the difference between the Emissions(kt) of Andorra in 2003 and the Emissions(kt) of Cameroon in 2005?
Your response must be concise. -2662.24. What is the difference between the Emissions(kt) in Andorra in 2003 and the Emissions(kt) in Niger in 2005?
Your response must be concise. 106.34. What is the difference between the Emissions(kt) in Andorra in 2003 and the Emissions(kt) in Suriname in 2005?
Your response must be concise. -1811.5. What is the difference between the Emissions(kt) in Cameroon in 2003 and the Emissions(kt) in Niger in 2005?
Your response must be concise. 2893.26. What is the difference between the Emissions(kt) of Cameroon in 2003 and the Emissions(kt) of Suriname in 2005?
Make the answer very short. 975.42. What is the difference between the Emissions(kt) in Niger in 2003 and the Emissions(kt) in Suriname in 2005?
Provide a short and direct response. -1884.84. What is the difference between the Emissions(kt) of Andorra in 2003 and the Emissions(kt) of Cameroon in 2006?
Ensure brevity in your answer.  -2827.26. What is the difference between the Emissions(kt) in Andorra in 2003 and the Emissions(kt) in Niger in 2006?
Give a very brief answer. 135.68. What is the difference between the Emissions(kt) of Andorra in 2003 and the Emissions(kt) of Suriname in 2006?
Make the answer very short. -1873.84. What is the difference between the Emissions(kt) of Cameroon in 2003 and the Emissions(kt) of Niger in 2006?
Ensure brevity in your answer.  2922.6. What is the difference between the Emissions(kt) of Cameroon in 2003 and the Emissions(kt) of Suriname in 2006?
Your answer should be very brief. 913.08. What is the difference between the Emissions(kt) of Niger in 2003 and the Emissions(kt) of Suriname in 2006?
Keep it short and to the point. -1947.18. What is the difference between the Emissions(kt) of Andorra in 2004 and the Emissions(kt) of Cameroon in 2005?
Keep it short and to the point. -2632.91. What is the difference between the Emissions(kt) of Andorra in 2004 and the Emissions(kt) of Niger in 2005?
Give a very brief answer. 135.68. What is the difference between the Emissions(kt) in Andorra in 2004 and the Emissions(kt) in Suriname in 2005?
Your response must be concise. -1782.16. What is the difference between the Emissions(kt) in Cameroon in 2004 and the Emissions(kt) in Niger in 2005?
Your answer should be compact. 3014.27. What is the difference between the Emissions(kt) in Cameroon in 2004 and the Emissions(kt) in Suriname in 2005?
Give a very brief answer. 1096.43. What is the difference between the Emissions(kt) in Niger in 2004 and the Emissions(kt) in Suriname in 2005?
Provide a succinct answer. -1910.51. What is the difference between the Emissions(kt) of Andorra in 2004 and the Emissions(kt) of Cameroon in 2006?
Your answer should be compact. -2797.92. What is the difference between the Emissions(kt) in Andorra in 2004 and the Emissions(kt) in Niger in 2006?
Make the answer very short. 165.01. What is the difference between the Emissions(kt) of Andorra in 2004 and the Emissions(kt) of Suriname in 2006?
Offer a very short reply. -1844.5. What is the difference between the Emissions(kt) in Cameroon in 2004 and the Emissions(kt) in Niger in 2006?
Offer a very short reply. 3043.61. What is the difference between the Emissions(kt) of Cameroon in 2004 and the Emissions(kt) of Suriname in 2006?
Keep it short and to the point. 1034.09. What is the difference between the Emissions(kt) of Niger in 2004 and the Emissions(kt) of Suriname in 2006?
Keep it short and to the point. -1972.85. What is the difference between the Emissions(kt) in Andorra in 2005 and the Emissions(kt) in Cameroon in 2006?
Offer a terse response. -2786.92. What is the difference between the Emissions(kt) of Andorra in 2005 and the Emissions(kt) of Niger in 2006?
Provide a short and direct response. 176.02. What is the difference between the Emissions(kt) in Andorra in 2005 and the Emissions(kt) in Suriname in 2006?
Your answer should be very brief. -1833.5. What is the difference between the Emissions(kt) in Cameroon in 2005 and the Emissions(kt) in Niger in 2006?
Make the answer very short. 2797.92. What is the difference between the Emissions(kt) in Cameroon in 2005 and the Emissions(kt) in Suriname in 2006?
Keep it short and to the point. 788.4. What is the difference between the Emissions(kt) in Niger in 2005 and the Emissions(kt) in Suriname in 2006?
Keep it short and to the point. -1980.18. What is the average Emissions(kt) in Andorra per year?
Your response must be concise. 539.51. What is the average Emissions(kt) in Cameroon per year?
Provide a succinct answer. 3106.87. What is the average Emissions(kt) of Niger per year?
Offer a very short reply. 459.29. What is the average Emissions(kt) in Suriname per year?
Your response must be concise. 2236.87. In the year 1999, what is the difference between the Emissions(kt) of Andorra and Emissions(kt) of Cameroon?
Give a very brief answer. -2141.53. In the year 1999, what is the difference between the Emissions(kt) in Andorra and Emissions(kt) in Niger?
Offer a very short reply. -179.68. In the year 1999, what is the difference between the Emissions(kt) in Andorra and Emissions(kt) in Suriname?
Your response must be concise. -1609.81. In the year 1999, what is the difference between the Emissions(kt) of Cameroon and Emissions(kt) of Niger?
Your answer should be compact. 1961.85. In the year 1999, what is the difference between the Emissions(kt) of Cameroon and Emissions(kt) of Suriname?
Provide a succinct answer. 531.72. In the year 1999, what is the difference between the Emissions(kt) in Niger and Emissions(kt) in Suriname?
Make the answer very short. -1430.13. In the year 2000, what is the difference between the Emissions(kt) of Andorra and Emissions(kt) of Cameroon?
Offer a very short reply. -2464.22. In the year 2000, what is the difference between the Emissions(kt) of Andorra and Emissions(kt) of Niger?
Ensure brevity in your answer.  77.01. In the year 2000, what is the difference between the Emissions(kt) in Andorra and Emissions(kt) in Suriname?
Your answer should be compact. -1573.14. In the year 2000, what is the difference between the Emissions(kt) in Cameroon and Emissions(kt) in Niger?
Give a very brief answer. 2541.23. In the year 2000, what is the difference between the Emissions(kt) of Cameroon and Emissions(kt) of Suriname?
Provide a succinct answer. 891.08. In the year 2000, what is the difference between the Emissions(kt) in Niger and Emissions(kt) in Suriname?
Offer a terse response. -1650.15. In the year 2001, what is the difference between the Emissions(kt) in Andorra and Emissions(kt) in Cameroon?
Keep it short and to the point. -2409.22. In the year 2001, what is the difference between the Emissions(kt) of Andorra and Emissions(kt) of Niger?
Provide a succinct answer. 124.68. In the year 2001, what is the difference between the Emissions(kt) of Andorra and Emissions(kt) of Suriname?
Give a very brief answer. -1708.82. In the year 2001, what is the difference between the Emissions(kt) in Cameroon and Emissions(kt) in Niger?
Make the answer very short. 2533.9. In the year 2001, what is the difference between the Emissions(kt) of Cameroon and Emissions(kt) of Suriname?
Provide a succinct answer. 700.4. In the year 2001, what is the difference between the Emissions(kt) of Niger and Emissions(kt) of Suriname?
Your answer should be very brief. -1833.5. In the year 2002, what is the difference between the Emissions(kt) of Andorra and Emissions(kt) of Cameroon?
Keep it short and to the point. -2420.22. In the year 2002, what is the difference between the Emissions(kt) in Andorra and Emissions(kt) in Niger?
Your response must be concise. 124.68. In the year 2002, what is the difference between the Emissions(kt) of Andorra and Emissions(kt) of Suriname?
Provide a succinct answer. -1686.82. In the year 2002, what is the difference between the Emissions(kt) of Cameroon and Emissions(kt) of Niger?
Keep it short and to the point. 2544.9. In the year 2002, what is the difference between the Emissions(kt) in Cameroon and Emissions(kt) in Suriname?
Give a very brief answer. 733.4. In the year 2002, what is the difference between the Emissions(kt) in Niger and Emissions(kt) in Suriname?
Provide a succinct answer. -1811.5. In the year 2003, what is the difference between the Emissions(kt) in Andorra and Emissions(kt) in Cameroon?
Make the answer very short. -2786.92. In the year 2003, what is the difference between the Emissions(kt) in Andorra and Emissions(kt) in Niger?
Offer a very short reply. 73.34. In the year 2003, what is the difference between the Emissions(kt) of Andorra and Emissions(kt) of Suriname?
Provide a succinct answer. -1672.15. In the year 2003, what is the difference between the Emissions(kt) in Cameroon and Emissions(kt) in Niger?
Ensure brevity in your answer.  2860.26. In the year 2003, what is the difference between the Emissions(kt) in Cameroon and Emissions(kt) in Suriname?
Keep it short and to the point. 1114.77. In the year 2003, what is the difference between the Emissions(kt) in Niger and Emissions(kt) in Suriname?
Offer a very short reply. -1745.49. In the year 2004, what is the difference between the Emissions(kt) in Andorra and Emissions(kt) in Cameroon?
Your response must be concise. -2878.59. In the year 2004, what is the difference between the Emissions(kt) in Andorra and Emissions(kt) in Niger?
Give a very brief answer. 128.34. In the year 2004, what is the difference between the Emissions(kt) of Andorra and Emissions(kt) of Suriname?
Provide a short and direct response. -1694.15. In the year 2004, what is the difference between the Emissions(kt) in Cameroon and Emissions(kt) in Niger?
Provide a short and direct response. 3006.94. In the year 2004, what is the difference between the Emissions(kt) in Cameroon and Emissions(kt) in Suriname?
Provide a succinct answer. 1184.44. In the year 2004, what is the difference between the Emissions(kt) in Niger and Emissions(kt) in Suriname?
Provide a succinct answer. -1822.5. In the year 2005, what is the difference between the Emissions(kt) in Andorra and Emissions(kt) in Cameroon?
Ensure brevity in your answer.  -2621.91. In the year 2005, what is the difference between the Emissions(kt) of Andorra and Emissions(kt) of Niger?
Your response must be concise. 146.68. In the year 2005, what is the difference between the Emissions(kt) of Andorra and Emissions(kt) of Suriname?
Your response must be concise. -1771.16. In the year 2005, what is the difference between the Emissions(kt) in Cameroon and Emissions(kt) in Niger?
Offer a very short reply. 2768.59. In the year 2005, what is the difference between the Emissions(kt) in Cameroon and Emissions(kt) in Suriname?
Your response must be concise. 850.74. In the year 2005, what is the difference between the Emissions(kt) in Niger and Emissions(kt) in Suriname?
Your answer should be compact. -1917.84. In the year 2006, what is the difference between the Emissions(kt) in Andorra and Emissions(kt) in Cameroon?
Offer a terse response. -2816.26. In the year 2006, what is the difference between the Emissions(kt) in Andorra and Emissions(kt) in Niger?
Make the answer very short. 146.68. In the year 2006, what is the difference between the Emissions(kt) of Andorra and Emissions(kt) of Suriname?
Make the answer very short. -1862.84. In the year 2006, what is the difference between the Emissions(kt) of Cameroon and Emissions(kt) of Niger?
Your answer should be compact. 2962.94. In the year 2006, what is the difference between the Emissions(kt) in Cameroon and Emissions(kt) in Suriname?
Keep it short and to the point. 953.42. In the year 2006, what is the difference between the Emissions(kt) in Niger and Emissions(kt) in Suriname?
Keep it short and to the point. -2009.52. What is the ratio of the Emissions(kt) of Andorra in 1999 to that in 2000?
Your answer should be compact. 0.98. What is the ratio of the Emissions(kt) of Cameroon in 1999 to that in 2000?
Make the answer very short. 0.89. What is the ratio of the Emissions(kt) in Niger in 1999 to that in 2000?
Make the answer very short. 1.55. What is the ratio of the Emissions(kt) of Suriname in 1999 to that in 2000?
Your answer should be compact. 1.01. What is the ratio of the Emissions(kt) in Cameroon in 1999 to that in 2001?
Your answer should be very brief. 0.91. What is the ratio of the Emissions(kt) of Niger in 1999 to that in 2001?
Offer a very short reply. 1.73. What is the ratio of the Emissions(kt) of Suriname in 1999 to that in 2001?
Keep it short and to the point. 0.95. What is the ratio of the Emissions(kt) of Andorra in 1999 to that in 2002?
Your answer should be compact. 0.97. What is the ratio of the Emissions(kt) of Cameroon in 1999 to that in 2002?
Offer a very short reply. 0.9. What is the ratio of the Emissions(kt) in Niger in 1999 to that in 2002?
Provide a succinct answer. 1.7. What is the ratio of the Emissions(kt) of Suriname in 1999 to that in 2002?
Make the answer very short. 0.96. What is the ratio of the Emissions(kt) in Andorra in 1999 to that in 2003?
Offer a very short reply. 0.96. What is the ratio of the Emissions(kt) of Cameroon in 1999 to that in 2003?
Your answer should be very brief. 0.8. What is the ratio of the Emissions(kt) of Niger in 1999 to that in 2003?
Offer a very short reply. 1.5. What is the ratio of the Emissions(kt) of Suriname in 1999 to that in 2003?
Make the answer very short. 0.96. What is the ratio of the Emissions(kt) in Andorra in 1999 to that in 2004?
Your answer should be very brief. 0.91. What is the ratio of the Emissions(kt) in Cameroon in 1999 to that in 2004?
Offer a very short reply. 0.77. What is the ratio of the Emissions(kt) in Niger in 1999 to that in 2004?
Ensure brevity in your answer.  1.59. What is the ratio of the Emissions(kt) of Suriname in 1999 to that in 2004?
Ensure brevity in your answer.  0.94. What is the ratio of the Emissions(kt) in Andorra in 1999 to that in 2005?
Give a very brief answer. 0.89. What is the ratio of the Emissions(kt) in Cameroon in 1999 to that in 2005?
Offer a very short reply. 0.83. What is the ratio of the Emissions(kt) of Niger in 1999 to that in 2005?
Keep it short and to the point. 1.62. What is the ratio of the Emissions(kt) of Suriname in 1999 to that in 2005?
Ensure brevity in your answer.  0.9. What is the ratio of the Emissions(kt) in Andorra in 1999 to that in 2006?
Give a very brief answer. 0.94. What is the ratio of the Emissions(kt) of Cameroon in 1999 to that in 2006?
Your response must be concise. 0.79. What is the ratio of the Emissions(kt) of Niger in 1999 to that in 2006?
Provide a short and direct response. 1.73. What is the ratio of the Emissions(kt) in Suriname in 1999 to that in 2006?
Your answer should be very brief. 0.88. What is the ratio of the Emissions(kt) in Andorra in 2000 to that in 2001?
Keep it short and to the point. 1. What is the ratio of the Emissions(kt) of Cameroon in 2000 to that in 2001?
Give a very brief answer. 1.02. What is the ratio of the Emissions(kt) in Niger in 2000 to that in 2001?
Make the answer very short. 1.12. What is the ratio of the Emissions(kt) in Suriname in 2000 to that in 2001?
Your response must be concise. 0.94. What is the ratio of the Emissions(kt) of Andorra in 2000 to that in 2002?
Offer a terse response. 0.99. What is the ratio of the Emissions(kt) in Cameroon in 2000 to that in 2002?
Offer a very short reply. 1.01. What is the ratio of the Emissions(kt) in Niger in 2000 to that in 2002?
Offer a very short reply. 1.1. What is the ratio of the Emissions(kt) of Suriname in 2000 to that in 2002?
Provide a short and direct response. 0.95. What is the ratio of the Emissions(kt) of Andorra in 2000 to that in 2003?
Provide a succinct answer. 0.98. What is the ratio of the Emissions(kt) in Cameroon in 2000 to that in 2003?
Your response must be concise. 0.9. What is the ratio of the Emissions(kt) in Niger in 2000 to that in 2003?
Keep it short and to the point. 0.97. What is the ratio of the Emissions(kt) of Suriname in 2000 to that in 2003?
Your response must be concise. 0.95. What is the ratio of the Emissions(kt) in Andorra in 2000 to that in 2004?
Make the answer very short. 0.93. What is the ratio of the Emissions(kt) of Cameroon in 2000 to that in 2004?
Offer a very short reply. 0.87. What is the ratio of the Emissions(kt) in Niger in 2000 to that in 2004?
Your answer should be compact. 1.03. What is the ratio of the Emissions(kt) in Suriname in 2000 to that in 2004?
Give a very brief answer. 0.93. What is the ratio of the Emissions(kt) of Andorra in 2000 to that in 2005?
Make the answer very short. 0.91. What is the ratio of the Emissions(kt) of Cameroon in 2000 to that in 2005?
Provide a short and direct response. 0.93. What is the ratio of the Emissions(kt) in Niger in 2000 to that in 2005?
Your response must be concise. 1.04. What is the ratio of the Emissions(kt) in Suriname in 2000 to that in 2005?
Provide a short and direct response. 0.89. What is the ratio of the Emissions(kt) in Andorra in 2000 to that in 2006?
Offer a very short reply. 0.96. What is the ratio of the Emissions(kt) in Cameroon in 2000 to that in 2006?
Provide a short and direct response. 0.89. What is the ratio of the Emissions(kt) of Niger in 2000 to that in 2006?
Offer a terse response. 1.12. What is the ratio of the Emissions(kt) in Suriname in 2000 to that in 2006?
Give a very brief answer. 0.87. What is the ratio of the Emissions(kt) in Andorra in 2001 to that in 2002?
Your response must be concise. 0.99. What is the ratio of the Emissions(kt) of Suriname in 2001 to that in 2002?
Your response must be concise. 1.01. What is the ratio of the Emissions(kt) of Andorra in 2001 to that in 2003?
Make the answer very short. 0.98. What is the ratio of the Emissions(kt) of Cameroon in 2001 to that in 2003?
Provide a succinct answer. 0.88. What is the ratio of the Emissions(kt) of Niger in 2001 to that in 2003?
Offer a very short reply. 0.87. What is the ratio of the Emissions(kt) in Suriname in 2001 to that in 2003?
Your answer should be compact. 1.01. What is the ratio of the Emissions(kt) in Andorra in 2001 to that in 2004?
Your answer should be compact. 0.93. What is the ratio of the Emissions(kt) of Cameroon in 2001 to that in 2004?
Provide a short and direct response. 0.85. What is the ratio of the Emissions(kt) in Niger in 2001 to that in 2004?
Provide a short and direct response. 0.92. What is the ratio of the Emissions(kt) of Andorra in 2001 to that in 2005?
Your answer should be very brief. 0.91. What is the ratio of the Emissions(kt) of Cameroon in 2001 to that in 2005?
Keep it short and to the point. 0.92. What is the ratio of the Emissions(kt) in Niger in 2001 to that in 2005?
Your answer should be very brief. 0.93. What is the ratio of the Emissions(kt) in Suriname in 2001 to that in 2005?
Keep it short and to the point. 0.95. What is the ratio of the Emissions(kt) of Andorra in 2001 to that in 2006?
Your answer should be very brief. 0.96. What is the ratio of the Emissions(kt) in Cameroon in 2001 to that in 2006?
Make the answer very short. 0.87. What is the ratio of the Emissions(kt) in Niger in 2001 to that in 2006?
Your answer should be compact. 1. What is the ratio of the Emissions(kt) of Suriname in 2001 to that in 2006?
Provide a short and direct response. 0.93. What is the ratio of the Emissions(kt) in Andorra in 2002 to that in 2003?
Offer a very short reply. 0.99. What is the ratio of the Emissions(kt) in Cameroon in 2002 to that in 2003?
Provide a succinct answer. 0.89. What is the ratio of the Emissions(kt) of Niger in 2002 to that in 2003?
Make the answer very short. 0.88. What is the ratio of the Emissions(kt) in Suriname in 2002 to that in 2003?
Provide a short and direct response. 1. What is the ratio of the Emissions(kt) of Andorra in 2002 to that in 2004?
Give a very brief answer. 0.94. What is the ratio of the Emissions(kt) in Cameroon in 2002 to that in 2004?
Your answer should be compact. 0.86. What is the ratio of the Emissions(kt) of Niger in 2002 to that in 2004?
Ensure brevity in your answer.  0.93. What is the ratio of the Emissions(kt) of Suriname in 2002 to that in 2004?
Your response must be concise. 0.98. What is the ratio of the Emissions(kt) in Andorra in 2002 to that in 2005?
Keep it short and to the point. 0.92. What is the ratio of the Emissions(kt) of Cameroon in 2002 to that in 2005?
Provide a short and direct response. 0.92. What is the ratio of the Emissions(kt) in Niger in 2002 to that in 2005?
Give a very brief answer. 0.95. What is the ratio of the Emissions(kt) of Suriname in 2002 to that in 2005?
Your response must be concise. 0.95. What is the ratio of the Emissions(kt) of Andorra in 2002 to that in 2006?
Your answer should be very brief. 0.97. What is the ratio of the Emissions(kt) in Cameroon in 2002 to that in 2006?
Your answer should be very brief. 0.88. What is the ratio of the Emissions(kt) in Niger in 2002 to that in 2006?
Ensure brevity in your answer.  1.02. What is the ratio of the Emissions(kt) of Suriname in 2002 to that in 2006?
Ensure brevity in your answer.  0.92. What is the ratio of the Emissions(kt) of Andorra in 2003 to that in 2004?
Make the answer very short. 0.95. What is the ratio of the Emissions(kt) of Cameroon in 2003 to that in 2004?
Make the answer very short. 0.96. What is the ratio of the Emissions(kt) in Niger in 2003 to that in 2004?
Provide a short and direct response. 1.06. What is the ratio of the Emissions(kt) of Suriname in 2003 to that in 2004?
Make the answer very short. 0.98. What is the ratio of the Emissions(kt) of Andorra in 2003 to that in 2005?
Ensure brevity in your answer.  0.93. What is the ratio of the Emissions(kt) of Cameroon in 2003 to that in 2005?
Provide a succinct answer. 1.04. What is the ratio of the Emissions(kt) of Suriname in 2003 to that in 2005?
Provide a short and direct response. 0.94. What is the ratio of the Emissions(kt) in Andorra in 2003 to that in 2006?
Offer a terse response. 0.98. What is the ratio of the Emissions(kt) in Cameroon in 2003 to that in 2006?
Make the answer very short. 0.99. What is the ratio of the Emissions(kt) in Niger in 2003 to that in 2006?
Your answer should be compact. 1.16. What is the ratio of the Emissions(kt) in Suriname in 2003 to that in 2006?
Your answer should be compact. 0.92. What is the ratio of the Emissions(kt) in Andorra in 2004 to that in 2005?
Ensure brevity in your answer.  0.98. What is the ratio of the Emissions(kt) in Cameroon in 2004 to that in 2005?
Your answer should be very brief. 1.08. What is the ratio of the Emissions(kt) of Niger in 2004 to that in 2005?
Offer a very short reply. 1.02. What is the ratio of the Emissions(kt) in Suriname in 2004 to that in 2005?
Keep it short and to the point. 0.96. What is the ratio of the Emissions(kt) of Andorra in 2004 to that in 2006?
Ensure brevity in your answer.  1.03. What is the ratio of the Emissions(kt) of Cameroon in 2004 to that in 2006?
Offer a terse response. 1.02. What is the ratio of the Emissions(kt) of Niger in 2004 to that in 2006?
Provide a succinct answer. 1.09. What is the ratio of the Emissions(kt) of Suriname in 2004 to that in 2006?
Your response must be concise. 0.94. What is the ratio of the Emissions(kt) of Andorra in 2005 to that in 2006?
Keep it short and to the point. 1.05. What is the ratio of the Emissions(kt) of Cameroon in 2005 to that in 2006?
Your answer should be very brief. 0.95. What is the ratio of the Emissions(kt) of Niger in 2005 to that in 2006?
Ensure brevity in your answer.  1.07. What is the ratio of the Emissions(kt) of Suriname in 2005 to that in 2006?
Offer a very short reply. 0.97. What is the difference between the highest and the second highest Emissions(kt) of Andorra?
Provide a short and direct response. 11. What is the difference between the highest and the second highest Emissions(kt) in Cameroon?
Offer a terse response. 80.67. What is the difference between the highest and the second highest Emissions(kt) in Niger?
Offer a very short reply. 231.02. What is the difference between the highest and the second highest Emissions(kt) of Suriname?
Make the answer very short. 62.34. What is the difference between the highest and the lowest Emissions(kt) of Andorra?
Make the answer very short. 62.34. What is the difference between the highest and the lowest Emissions(kt) in Cameroon?
Offer a terse response. 788.4. What is the difference between the highest and the lowest Emissions(kt) in Niger?
Offer a terse response. 293.36. What is the difference between the highest and the lowest Emissions(kt) of Suriname?
Ensure brevity in your answer.  311.69. 